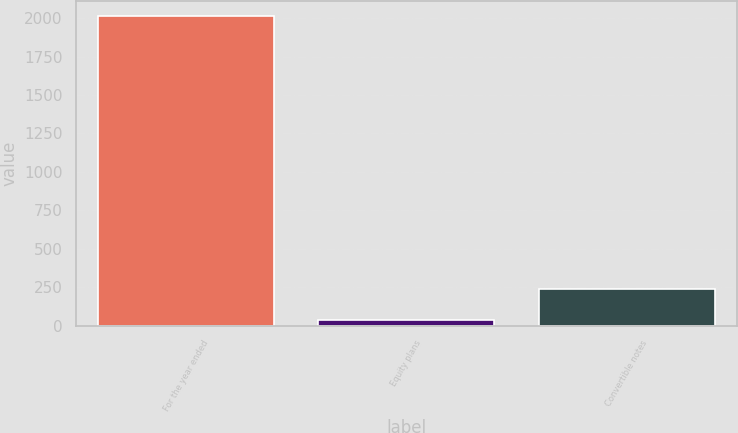<chart> <loc_0><loc_0><loc_500><loc_500><bar_chart><fcel>For the year ended<fcel>Equity plans<fcel>Convertible notes<nl><fcel>2013<fcel>40<fcel>237.3<nl></chart> 